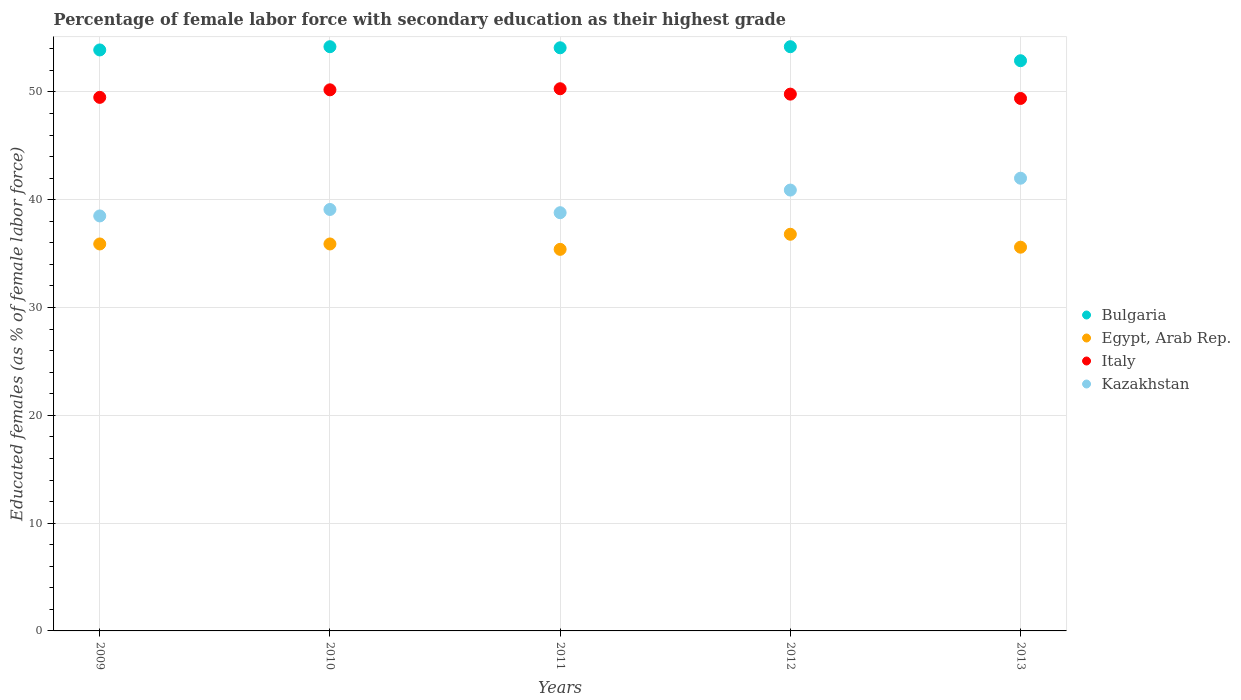What is the percentage of female labor force with secondary education in Bulgaria in 2012?
Offer a very short reply. 54.2. Across all years, what is the maximum percentage of female labor force with secondary education in Egypt, Arab Rep.?
Make the answer very short. 36.8. Across all years, what is the minimum percentage of female labor force with secondary education in Kazakhstan?
Give a very brief answer. 38.5. In which year was the percentage of female labor force with secondary education in Egypt, Arab Rep. minimum?
Your answer should be compact. 2011. What is the total percentage of female labor force with secondary education in Egypt, Arab Rep. in the graph?
Provide a succinct answer. 179.6. What is the difference between the percentage of female labor force with secondary education in Italy in 2010 and that in 2012?
Offer a very short reply. 0.4. What is the difference between the percentage of female labor force with secondary education in Kazakhstan in 2013 and the percentage of female labor force with secondary education in Egypt, Arab Rep. in 2012?
Keep it short and to the point. 5.2. What is the average percentage of female labor force with secondary education in Italy per year?
Your answer should be very brief. 49.84. In the year 2011, what is the difference between the percentage of female labor force with secondary education in Egypt, Arab Rep. and percentage of female labor force with secondary education in Kazakhstan?
Offer a very short reply. -3.4. What is the ratio of the percentage of female labor force with secondary education in Kazakhstan in 2009 to that in 2013?
Your answer should be very brief. 0.92. Is the percentage of female labor force with secondary education in Italy in 2011 less than that in 2012?
Keep it short and to the point. No. Is the difference between the percentage of female labor force with secondary education in Egypt, Arab Rep. in 2010 and 2013 greater than the difference between the percentage of female labor force with secondary education in Kazakhstan in 2010 and 2013?
Your answer should be very brief. Yes. What is the difference between the highest and the second highest percentage of female labor force with secondary education in Kazakhstan?
Your answer should be compact. 1.1. What is the difference between the highest and the lowest percentage of female labor force with secondary education in Bulgaria?
Offer a very short reply. 1.3. In how many years, is the percentage of female labor force with secondary education in Kazakhstan greater than the average percentage of female labor force with secondary education in Kazakhstan taken over all years?
Offer a terse response. 2. Is the sum of the percentage of female labor force with secondary education in Kazakhstan in 2012 and 2013 greater than the maximum percentage of female labor force with secondary education in Italy across all years?
Provide a short and direct response. Yes. Is it the case that in every year, the sum of the percentage of female labor force with secondary education in Egypt, Arab Rep. and percentage of female labor force with secondary education in Italy  is greater than the percentage of female labor force with secondary education in Kazakhstan?
Offer a very short reply. Yes. How many years are there in the graph?
Offer a very short reply. 5. Does the graph contain any zero values?
Offer a terse response. No. How are the legend labels stacked?
Offer a terse response. Vertical. What is the title of the graph?
Provide a short and direct response. Percentage of female labor force with secondary education as their highest grade. Does "Europe(developing only)" appear as one of the legend labels in the graph?
Keep it short and to the point. No. What is the label or title of the X-axis?
Your response must be concise. Years. What is the label or title of the Y-axis?
Offer a very short reply. Educated females (as % of female labor force). What is the Educated females (as % of female labor force) in Bulgaria in 2009?
Provide a short and direct response. 53.9. What is the Educated females (as % of female labor force) in Egypt, Arab Rep. in 2009?
Provide a succinct answer. 35.9. What is the Educated females (as % of female labor force) of Italy in 2009?
Make the answer very short. 49.5. What is the Educated females (as % of female labor force) in Kazakhstan in 2009?
Provide a succinct answer. 38.5. What is the Educated females (as % of female labor force) of Bulgaria in 2010?
Your response must be concise. 54.2. What is the Educated females (as % of female labor force) in Egypt, Arab Rep. in 2010?
Offer a very short reply. 35.9. What is the Educated females (as % of female labor force) in Italy in 2010?
Your answer should be compact. 50.2. What is the Educated females (as % of female labor force) in Kazakhstan in 2010?
Offer a very short reply. 39.1. What is the Educated females (as % of female labor force) of Bulgaria in 2011?
Your response must be concise. 54.1. What is the Educated females (as % of female labor force) of Egypt, Arab Rep. in 2011?
Keep it short and to the point. 35.4. What is the Educated females (as % of female labor force) in Italy in 2011?
Ensure brevity in your answer.  50.3. What is the Educated females (as % of female labor force) of Kazakhstan in 2011?
Ensure brevity in your answer.  38.8. What is the Educated females (as % of female labor force) in Bulgaria in 2012?
Your answer should be compact. 54.2. What is the Educated females (as % of female labor force) in Egypt, Arab Rep. in 2012?
Make the answer very short. 36.8. What is the Educated females (as % of female labor force) of Italy in 2012?
Ensure brevity in your answer.  49.8. What is the Educated females (as % of female labor force) of Kazakhstan in 2012?
Offer a terse response. 40.9. What is the Educated females (as % of female labor force) in Bulgaria in 2013?
Provide a short and direct response. 52.9. What is the Educated females (as % of female labor force) of Egypt, Arab Rep. in 2013?
Give a very brief answer. 35.6. What is the Educated females (as % of female labor force) in Italy in 2013?
Provide a short and direct response. 49.4. Across all years, what is the maximum Educated females (as % of female labor force) of Bulgaria?
Your answer should be compact. 54.2. Across all years, what is the maximum Educated females (as % of female labor force) in Egypt, Arab Rep.?
Offer a very short reply. 36.8. Across all years, what is the maximum Educated females (as % of female labor force) of Italy?
Ensure brevity in your answer.  50.3. Across all years, what is the minimum Educated females (as % of female labor force) in Bulgaria?
Keep it short and to the point. 52.9. Across all years, what is the minimum Educated females (as % of female labor force) in Egypt, Arab Rep.?
Give a very brief answer. 35.4. Across all years, what is the minimum Educated females (as % of female labor force) of Italy?
Offer a terse response. 49.4. Across all years, what is the minimum Educated females (as % of female labor force) in Kazakhstan?
Your answer should be compact. 38.5. What is the total Educated females (as % of female labor force) of Bulgaria in the graph?
Offer a terse response. 269.3. What is the total Educated females (as % of female labor force) of Egypt, Arab Rep. in the graph?
Your answer should be very brief. 179.6. What is the total Educated females (as % of female labor force) of Italy in the graph?
Make the answer very short. 249.2. What is the total Educated females (as % of female labor force) in Kazakhstan in the graph?
Offer a terse response. 199.3. What is the difference between the Educated females (as % of female labor force) of Bulgaria in 2009 and that in 2010?
Provide a short and direct response. -0.3. What is the difference between the Educated females (as % of female labor force) of Egypt, Arab Rep. in 2009 and that in 2010?
Ensure brevity in your answer.  0. What is the difference between the Educated females (as % of female labor force) in Italy in 2009 and that in 2010?
Your answer should be very brief. -0.7. What is the difference between the Educated females (as % of female labor force) of Kazakhstan in 2009 and that in 2010?
Offer a very short reply. -0.6. What is the difference between the Educated females (as % of female labor force) of Bulgaria in 2009 and that in 2011?
Offer a terse response. -0.2. What is the difference between the Educated females (as % of female labor force) of Italy in 2009 and that in 2011?
Give a very brief answer. -0.8. What is the difference between the Educated females (as % of female labor force) in Kazakhstan in 2009 and that in 2011?
Your response must be concise. -0.3. What is the difference between the Educated females (as % of female labor force) in Bulgaria in 2009 and that in 2012?
Your response must be concise. -0.3. What is the difference between the Educated females (as % of female labor force) of Egypt, Arab Rep. in 2009 and that in 2012?
Provide a short and direct response. -0.9. What is the difference between the Educated females (as % of female labor force) in Kazakhstan in 2009 and that in 2012?
Keep it short and to the point. -2.4. What is the difference between the Educated females (as % of female labor force) in Kazakhstan in 2009 and that in 2013?
Offer a very short reply. -3.5. What is the difference between the Educated females (as % of female labor force) in Egypt, Arab Rep. in 2010 and that in 2011?
Offer a terse response. 0.5. What is the difference between the Educated females (as % of female labor force) in Bulgaria in 2010 and that in 2012?
Offer a terse response. 0. What is the difference between the Educated females (as % of female labor force) of Bulgaria in 2010 and that in 2013?
Provide a succinct answer. 1.3. What is the difference between the Educated females (as % of female labor force) in Italy in 2010 and that in 2013?
Offer a very short reply. 0.8. What is the difference between the Educated females (as % of female labor force) in Kazakhstan in 2010 and that in 2013?
Make the answer very short. -2.9. What is the difference between the Educated females (as % of female labor force) of Egypt, Arab Rep. in 2011 and that in 2012?
Offer a very short reply. -1.4. What is the difference between the Educated females (as % of female labor force) in Bulgaria in 2011 and that in 2013?
Offer a terse response. 1.2. What is the difference between the Educated females (as % of female labor force) of Italy in 2011 and that in 2013?
Provide a short and direct response. 0.9. What is the difference between the Educated females (as % of female labor force) in Kazakhstan in 2011 and that in 2013?
Your answer should be very brief. -3.2. What is the difference between the Educated females (as % of female labor force) of Egypt, Arab Rep. in 2012 and that in 2013?
Keep it short and to the point. 1.2. What is the difference between the Educated females (as % of female labor force) of Italy in 2012 and that in 2013?
Give a very brief answer. 0.4. What is the difference between the Educated females (as % of female labor force) of Bulgaria in 2009 and the Educated females (as % of female labor force) of Italy in 2010?
Your answer should be compact. 3.7. What is the difference between the Educated females (as % of female labor force) in Bulgaria in 2009 and the Educated females (as % of female labor force) in Kazakhstan in 2010?
Provide a short and direct response. 14.8. What is the difference between the Educated females (as % of female labor force) of Egypt, Arab Rep. in 2009 and the Educated females (as % of female labor force) of Italy in 2010?
Ensure brevity in your answer.  -14.3. What is the difference between the Educated females (as % of female labor force) of Egypt, Arab Rep. in 2009 and the Educated females (as % of female labor force) of Kazakhstan in 2010?
Offer a very short reply. -3.2. What is the difference between the Educated females (as % of female labor force) in Italy in 2009 and the Educated females (as % of female labor force) in Kazakhstan in 2010?
Ensure brevity in your answer.  10.4. What is the difference between the Educated females (as % of female labor force) in Bulgaria in 2009 and the Educated females (as % of female labor force) in Egypt, Arab Rep. in 2011?
Ensure brevity in your answer.  18.5. What is the difference between the Educated females (as % of female labor force) in Bulgaria in 2009 and the Educated females (as % of female labor force) in Italy in 2011?
Keep it short and to the point. 3.6. What is the difference between the Educated females (as % of female labor force) of Bulgaria in 2009 and the Educated females (as % of female labor force) of Kazakhstan in 2011?
Your answer should be very brief. 15.1. What is the difference between the Educated females (as % of female labor force) of Egypt, Arab Rep. in 2009 and the Educated females (as % of female labor force) of Italy in 2011?
Provide a short and direct response. -14.4. What is the difference between the Educated females (as % of female labor force) of Egypt, Arab Rep. in 2009 and the Educated females (as % of female labor force) of Kazakhstan in 2011?
Make the answer very short. -2.9. What is the difference between the Educated females (as % of female labor force) in Italy in 2009 and the Educated females (as % of female labor force) in Kazakhstan in 2011?
Offer a terse response. 10.7. What is the difference between the Educated females (as % of female labor force) of Bulgaria in 2009 and the Educated females (as % of female labor force) of Egypt, Arab Rep. in 2012?
Offer a terse response. 17.1. What is the difference between the Educated females (as % of female labor force) in Bulgaria in 2009 and the Educated females (as % of female labor force) in Kazakhstan in 2012?
Your answer should be compact. 13. What is the difference between the Educated females (as % of female labor force) of Egypt, Arab Rep. in 2009 and the Educated females (as % of female labor force) of Italy in 2012?
Your answer should be very brief. -13.9. What is the difference between the Educated females (as % of female labor force) in Egypt, Arab Rep. in 2009 and the Educated females (as % of female labor force) in Kazakhstan in 2012?
Make the answer very short. -5. What is the difference between the Educated females (as % of female labor force) of Italy in 2009 and the Educated females (as % of female labor force) of Kazakhstan in 2012?
Make the answer very short. 8.6. What is the difference between the Educated females (as % of female labor force) in Bulgaria in 2009 and the Educated females (as % of female labor force) in Egypt, Arab Rep. in 2013?
Give a very brief answer. 18.3. What is the difference between the Educated females (as % of female labor force) in Bulgaria in 2009 and the Educated females (as % of female labor force) in Italy in 2013?
Provide a succinct answer. 4.5. What is the difference between the Educated females (as % of female labor force) of Egypt, Arab Rep. in 2009 and the Educated females (as % of female labor force) of Italy in 2013?
Your response must be concise. -13.5. What is the difference between the Educated females (as % of female labor force) in Egypt, Arab Rep. in 2009 and the Educated females (as % of female labor force) in Kazakhstan in 2013?
Ensure brevity in your answer.  -6.1. What is the difference between the Educated females (as % of female labor force) in Bulgaria in 2010 and the Educated females (as % of female labor force) in Kazakhstan in 2011?
Ensure brevity in your answer.  15.4. What is the difference between the Educated females (as % of female labor force) in Egypt, Arab Rep. in 2010 and the Educated females (as % of female labor force) in Italy in 2011?
Your answer should be compact. -14.4. What is the difference between the Educated females (as % of female labor force) in Bulgaria in 2010 and the Educated females (as % of female labor force) in Egypt, Arab Rep. in 2012?
Keep it short and to the point. 17.4. What is the difference between the Educated females (as % of female labor force) of Bulgaria in 2010 and the Educated females (as % of female labor force) of Egypt, Arab Rep. in 2013?
Your response must be concise. 18.6. What is the difference between the Educated females (as % of female labor force) in Bulgaria in 2010 and the Educated females (as % of female labor force) in Italy in 2013?
Offer a very short reply. 4.8. What is the difference between the Educated females (as % of female labor force) in Bulgaria in 2010 and the Educated females (as % of female labor force) in Kazakhstan in 2013?
Give a very brief answer. 12.2. What is the difference between the Educated females (as % of female labor force) in Italy in 2010 and the Educated females (as % of female labor force) in Kazakhstan in 2013?
Your response must be concise. 8.2. What is the difference between the Educated females (as % of female labor force) of Bulgaria in 2011 and the Educated females (as % of female labor force) of Italy in 2012?
Ensure brevity in your answer.  4.3. What is the difference between the Educated females (as % of female labor force) of Bulgaria in 2011 and the Educated females (as % of female labor force) of Kazakhstan in 2012?
Give a very brief answer. 13.2. What is the difference between the Educated females (as % of female labor force) of Egypt, Arab Rep. in 2011 and the Educated females (as % of female labor force) of Italy in 2012?
Make the answer very short. -14.4. What is the difference between the Educated females (as % of female labor force) in Italy in 2011 and the Educated females (as % of female labor force) in Kazakhstan in 2012?
Make the answer very short. 9.4. What is the difference between the Educated females (as % of female labor force) in Bulgaria in 2011 and the Educated females (as % of female labor force) in Italy in 2013?
Your answer should be compact. 4.7. What is the difference between the Educated females (as % of female labor force) of Egypt, Arab Rep. in 2011 and the Educated females (as % of female labor force) of Italy in 2013?
Offer a terse response. -14. What is the difference between the Educated females (as % of female labor force) in Italy in 2011 and the Educated females (as % of female labor force) in Kazakhstan in 2013?
Offer a very short reply. 8.3. What is the difference between the Educated females (as % of female labor force) of Bulgaria in 2012 and the Educated females (as % of female labor force) of Egypt, Arab Rep. in 2013?
Your answer should be very brief. 18.6. What is the difference between the Educated females (as % of female labor force) in Bulgaria in 2012 and the Educated females (as % of female labor force) in Italy in 2013?
Provide a short and direct response. 4.8. What is the difference between the Educated females (as % of female labor force) of Italy in 2012 and the Educated females (as % of female labor force) of Kazakhstan in 2013?
Make the answer very short. 7.8. What is the average Educated females (as % of female labor force) of Bulgaria per year?
Provide a short and direct response. 53.86. What is the average Educated females (as % of female labor force) in Egypt, Arab Rep. per year?
Make the answer very short. 35.92. What is the average Educated females (as % of female labor force) of Italy per year?
Provide a succinct answer. 49.84. What is the average Educated females (as % of female labor force) of Kazakhstan per year?
Keep it short and to the point. 39.86. In the year 2009, what is the difference between the Educated females (as % of female labor force) in Bulgaria and Educated females (as % of female labor force) in Italy?
Keep it short and to the point. 4.4. In the year 2009, what is the difference between the Educated females (as % of female labor force) in Egypt, Arab Rep. and Educated females (as % of female labor force) in Italy?
Your answer should be very brief. -13.6. In the year 2009, what is the difference between the Educated females (as % of female labor force) of Egypt, Arab Rep. and Educated females (as % of female labor force) of Kazakhstan?
Your response must be concise. -2.6. In the year 2010, what is the difference between the Educated females (as % of female labor force) in Bulgaria and Educated females (as % of female labor force) in Kazakhstan?
Offer a very short reply. 15.1. In the year 2010, what is the difference between the Educated females (as % of female labor force) of Egypt, Arab Rep. and Educated females (as % of female labor force) of Italy?
Keep it short and to the point. -14.3. In the year 2010, what is the difference between the Educated females (as % of female labor force) in Italy and Educated females (as % of female labor force) in Kazakhstan?
Provide a short and direct response. 11.1. In the year 2011, what is the difference between the Educated females (as % of female labor force) in Bulgaria and Educated females (as % of female labor force) in Egypt, Arab Rep.?
Provide a short and direct response. 18.7. In the year 2011, what is the difference between the Educated females (as % of female labor force) of Bulgaria and Educated females (as % of female labor force) of Italy?
Give a very brief answer. 3.8. In the year 2011, what is the difference between the Educated females (as % of female labor force) in Bulgaria and Educated females (as % of female labor force) in Kazakhstan?
Give a very brief answer. 15.3. In the year 2011, what is the difference between the Educated females (as % of female labor force) in Egypt, Arab Rep. and Educated females (as % of female labor force) in Italy?
Offer a terse response. -14.9. In the year 2011, what is the difference between the Educated females (as % of female labor force) in Egypt, Arab Rep. and Educated females (as % of female labor force) in Kazakhstan?
Your response must be concise. -3.4. In the year 2012, what is the difference between the Educated females (as % of female labor force) of Egypt, Arab Rep. and Educated females (as % of female labor force) of Kazakhstan?
Keep it short and to the point. -4.1. In the year 2012, what is the difference between the Educated females (as % of female labor force) in Italy and Educated females (as % of female labor force) in Kazakhstan?
Your response must be concise. 8.9. In the year 2013, what is the difference between the Educated females (as % of female labor force) of Bulgaria and Educated females (as % of female labor force) of Italy?
Keep it short and to the point. 3.5. In the year 2013, what is the difference between the Educated females (as % of female labor force) of Egypt, Arab Rep. and Educated females (as % of female labor force) of Kazakhstan?
Your answer should be very brief. -6.4. What is the ratio of the Educated females (as % of female labor force) in Italy in 2009 to that in 2010?
Keep it short and to the point. 0.99. What is the ratio of the Educated females (as % of female labor force) in Kazakhstan in 2009 to that in 2010?
Ensure brevity in your answer.  0.98. What is the ratio of the Educated females (as % of female labor force) in Bulgaria in 2009 to that in 2011?
Your response must be concise. 1. What is the ratio of the Educated females (as % of female labor force) in Egypt, Arab Rep. in 2009 to that in 2011?
Your answer should be very brief. 1.01. What is the ratio of the Educated females (as % of female labor force) of Italy in 2009 to that in 2011?
Offer a terse response. 0.98. What is the ratio of the Educated females (as % of female labor force) of Egypt, Arab Rep. in 2009 to that in 2012?
Offer a terse response. 0.98. What is the ratio of the Educated females (as % of female labor force) of Kazakhstan in 2009 to that in 2012?
Offer a very short reply. 0.94. What is the ratio of the Educated females (as % of female labor force) of Bulgaria in 2009 to that in 2013?
Your answer should be compact. 1.02. What is the ratio of the Educated females (as % of female labor force) in Egypt, Arab Rep. in 2009 to that in 2013?
Keep it short and to the point. 1.01. What is the ratio of the Educated females (as % of female labor force) of Italy in 2009 to that in 2013?
Ensure brevity in your answer.  1. What is the ratio of the Educated females (as % of female labor force) of Kazakhstan in 2009 to that in 2013?
Offer a very short reply. 0.92. What is the ratio of the Educated females (as % of female labor force) in Egypt, Arab Rep. in 2010 to that in 2011?
Make the answer very short. 1.01. What is the ratio of the Educated females (as % of female labor force) of Kazakhstan in 2010 to that in 2011?
Offer a very short reply. 1.01. What is the ratio of the Educated females (as % of female labor force) in Egypt, Arab Rep. in 2010 to that in 2012?
Offer a very short reply. 0.98. What is the ratio of the Educated females (as % of female labor force) of Kazakhstan in 2010 to that in 2012?
Provide a succinct answer. 0.96. What is the ratio of the Educated females (as % of female labor force) of Bulgaria in 2010 to that in 2013?
Give a very brief answer. 1.02. What is the ratio of the Educated females (as % of female labor force) of Egypt, Arab Rep. in 2010 to that in 2013?
Your response must be concise. 1.01. What is the ratio of the Educated females (as % of female labor force) in Italy in 2010 to that in 2013?
Keep it short and to the point. 1.02. What is the ratio of the Educated females (as % of female labor force) in Kazakhstan in 2010 to that in 2013?
Your answer should be very brief. 0.93. What is the ratio of the Educated females (as % of female labor force) in Italy in 2011 to that in 2012?
Your response must be concise. 1.01. What is the ratio of the Educated females (as % of female labor force) in Kazakhstan in 2011 to that in 2012?
Provide a succinct answer. 0.95. What is the ratio of the Educated females (as % of female labor force) of Bulgaria in 2011 to that in 2013?
Make the answer very short. 1.02. What is the ratio of the Educated females (as % of female labor force) of Italy in 2011 to that in 2013?
Ensure brevity in your answer.  1.02. What is the ratio of the Educated females (as % of female labor force) of Kazakhstan in 2011 to that in 2013?
Ensure brevity in your answer.  0.92. What is the ratio of the Educated females (as % of female labor force) of Bulgaria in 2012 to that in 2013?
Ensure brevity in your answer.  1.02. What is the ratio of the Educated females (as % of female labor force) of Egypt, Arab Rep. in 2012 to that in 2013?
Give a very brief answer. 1.03. What is the ratio of the Educated females (as % of female labor force) in Kazakhstan in 2012 to that in 2013?
Provide a succinct answer. 0.97. What is the difference between the highest and the second highest Educated females (as % of female labor force) of Bulgaria?
Your answer should be very brief. 0. What is the difference between the highest and the second highest Educated females (as % of female labor force) of Kazakhstan?
Your answer should be compact. 1.1. What is the difference between the highest and the lowest Educated females (as % of female labor force) of Bulgaria?
Your answer should be very brief. 1.3. What is the difference between the highest and the lowest Educated females (as % of female labor force) in Italy?
Offer a very short reply. 0.9. 